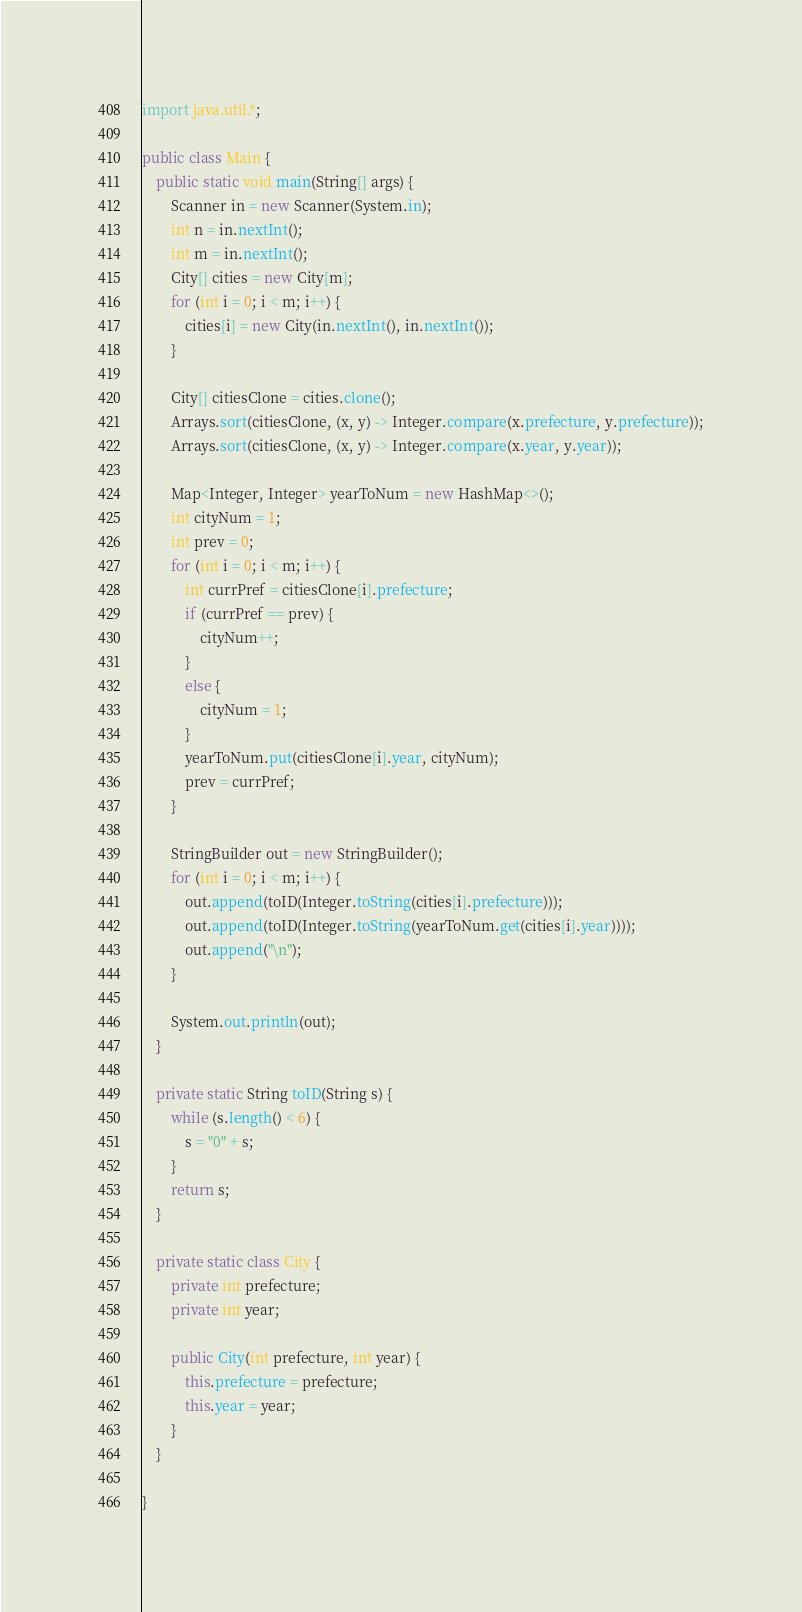Convert code to text. <code><loc_0><loc_0><loc_500><loc_500><_Java_>import java.util.*;

public class Main {
    public static void main(String[] args) {
        Scanner in = new Scanner(System.in);
        int n = in.nextInt();
        int m = in.nextInt();
        City[] cities = new City[m];
        for (int i = 0; i < m; i++) {
            cities[i] = new City(in.nextInt(), in.nextInt());
        }

        City[] citiesClone = cities.clone();
        Arrays.sort(citiesClone, (x, y) -> Integer.compare(x.prefecture, y.prefecture));
        Arrays.sort(citiesClone, (x, y) -> Integer.compare(x.year, y.year));

        Map<Integer, Integer> yearToNum = new HashMap<>();
        int cityNum = 1;
        int prev = 0;
        for (int i = 0; i < m; i++) {
            int currPref = citiesClone[i].prefecture;
            if (currPref == prev) {
                cityNum++;
            }
            else {
                cityNum = 1;
            }
            yearToNum.put(citiesClone[i].year, cityNum);
            prev = currPref;
        }

        StringBuilder out = new StringBuilder();
        for (int i = 0; i < m; i++) {
            out.append(toID(Integer.toString(cities[i].prefecture)));
            out.append(toID(Integer.toString(yearToNum.get(cities[i].year))));
            out.append("\n");
        }

        System.out.println(out);
    }

    private static String toID(String s) {
        while (s.length() < 6) {
            s = "0" + s;
        }
        return s;
    }

    private static class City {
        private int prefecture;
        private int year;

        public City(int prefecture, int year) {
            this.prefecture = prefecture;
            this.year = year;
        }
    }

}
</code> 